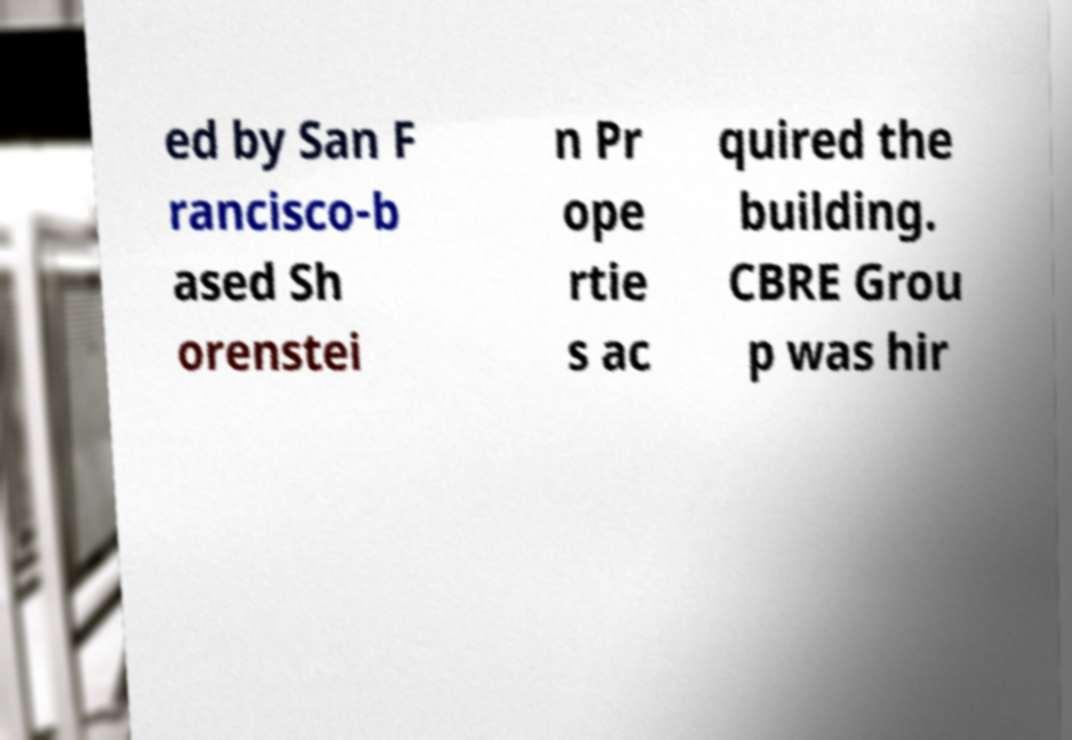Could you extract and type out the text from this image? ed by San F rancisco-b ased Sh orenstei n Pr ope rtie s ac quired the building. CBRE Grou p was hir 